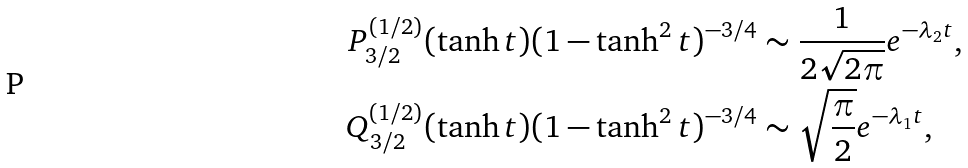<formula> <loc_0><loc_0><loc_500><loc_500>P _ { 3 / 2 } ^ { ( 1 / 2 ) } ( \tanh { t } ) ( 1 - \tanh ^ { 2 } { t } ) ^ { - 3 / 4 } & \sim \frac { 1 } { 2 \sqrt { 2 \pi } } e ^ { - \lambda _ { 2 } t } , \\ Q _ { 3 / 2 } ^ { ( 1 / 2 ) } ( \tanh { t } ) ( 1 - \tanh ^ { 2 } { t } ) ^ { - 3 / 4 } & \sim \sqrt { \frac { \pi } { 2 } } e ^ { - \lambda _ { 1 } t } ,</formula> 